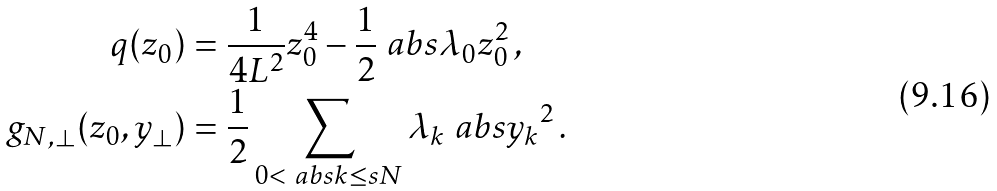<formula> <loc_0><loc_0><loc_500><loc_500>q ( z _ { 0 } ) & = \frac { 1 } { 4 L ^ { 2 } } z _ { 0 } ^ { 4 } - \frac { 1 } { 2 } \ a b s { \lambda _ { 0 } } z _ { 0 } ^ { 2 } \, , \\ g _ { N , \perp } ( z _ { 0 } , y _ { \perp } ) & = \frac { 1 } { 2 } \sum _ { 0 < \ a b s { k } \leq s N } \lambda _ { k } \ a b s { y _ { k } } ^ { 2 } \, .</formula> 